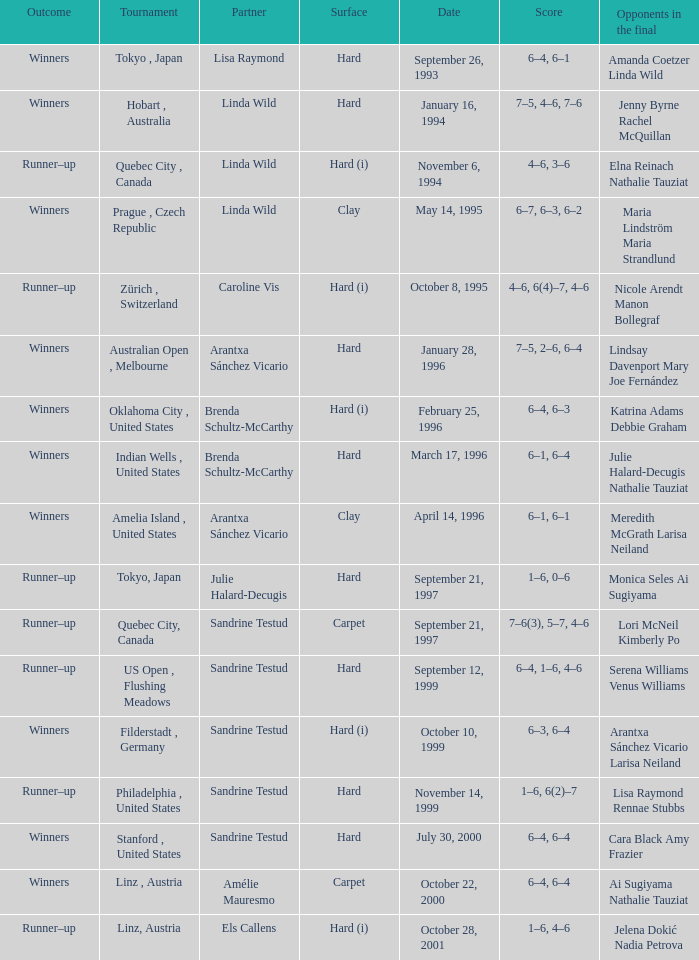Which surface had a partner of Sandrine Testud on November 14, 1999? Hard. 